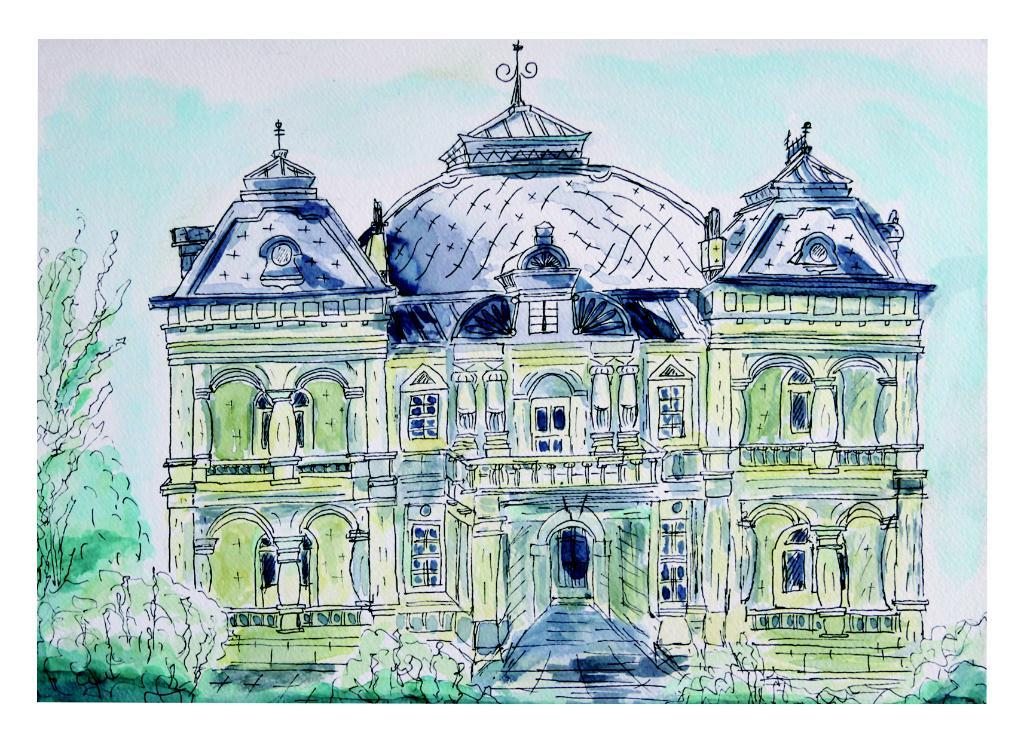What is depicted in the painting in the image? There is a painting of a building in the image. What type of vegetation can be seen in the image? There is a tree and plants in the image. What type of cheese is being served in the lunchroom in the image? There is no lunchroom or cheese present in the image; it features a painting of a building and plants. 